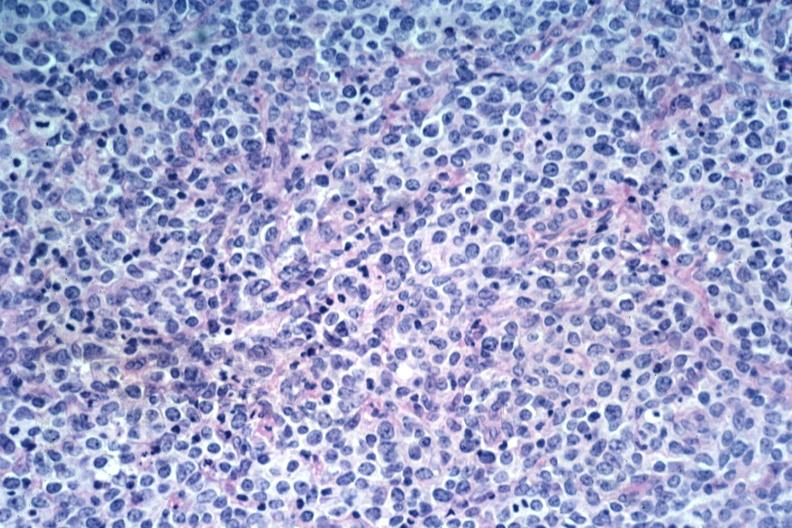s malignant lymphoma present?
Answer the question using a single word or phrase. Yes 